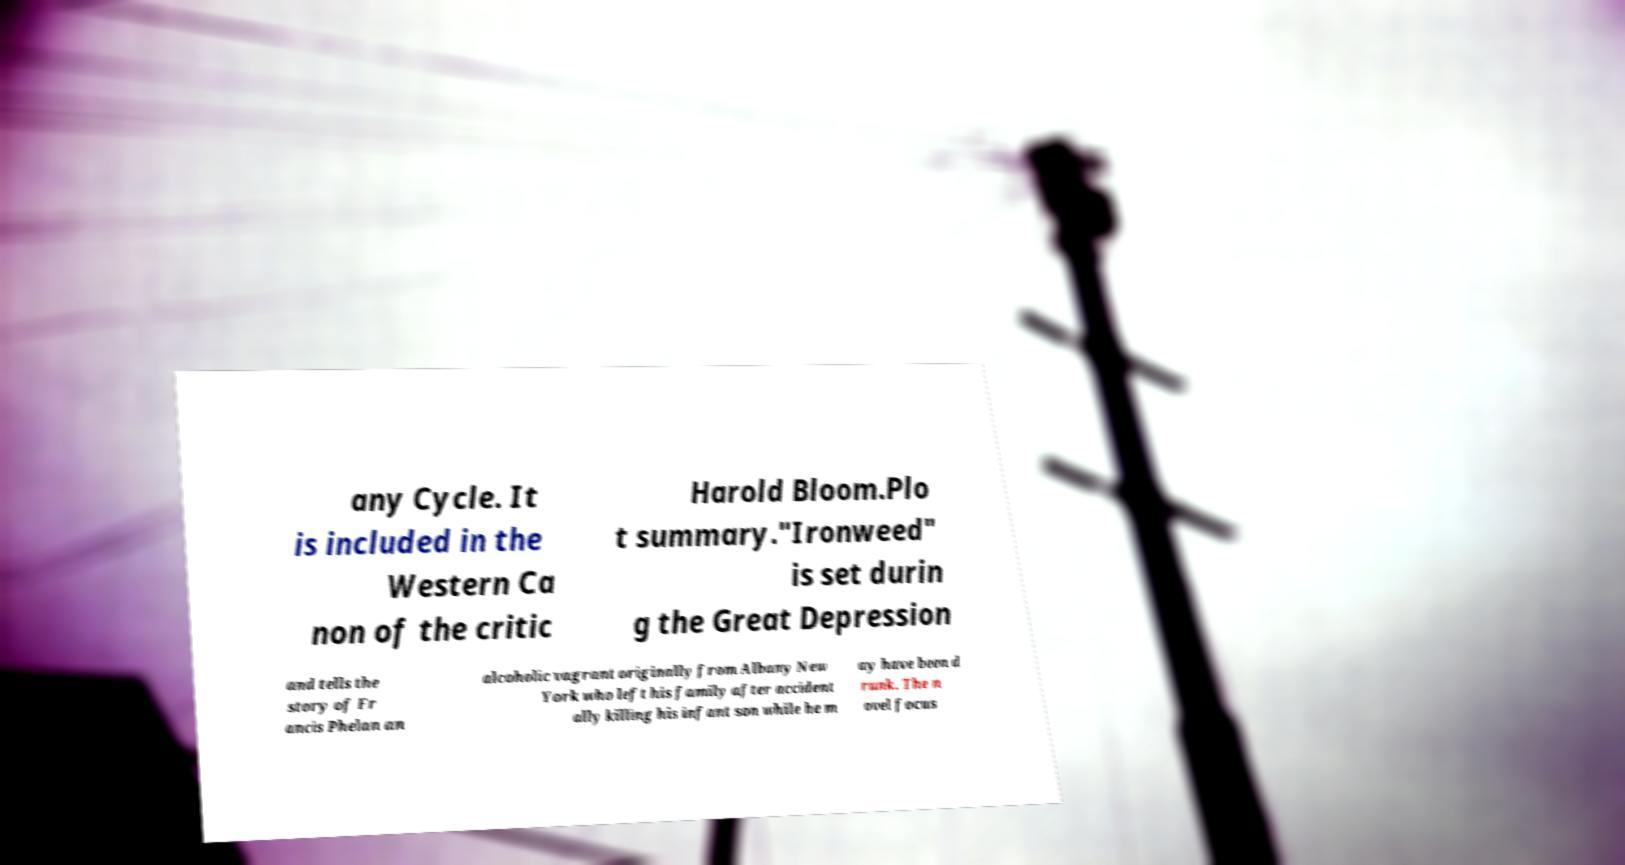There's text embedded in this image that I need extracted. Can you transcribe it verbatim? any Cycle. It is included in the Western Ca non of the critic Harold Bloom.Plo t summary."Ironweed" is set durin g the Great Depression and tells the story of Fr ancis Phelan an alcoholic vagrant originally from Albany New York who left his family after accident ally killing his infant son while he m ay have been d runk. The n ovel focus 